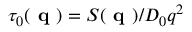<formula> <loc_0><loc_0><loc_500><loc_500>\tau _ { 0 } ( q ) = S ( q ) / D _ { 0 } q ^ { 2 }</formula> 